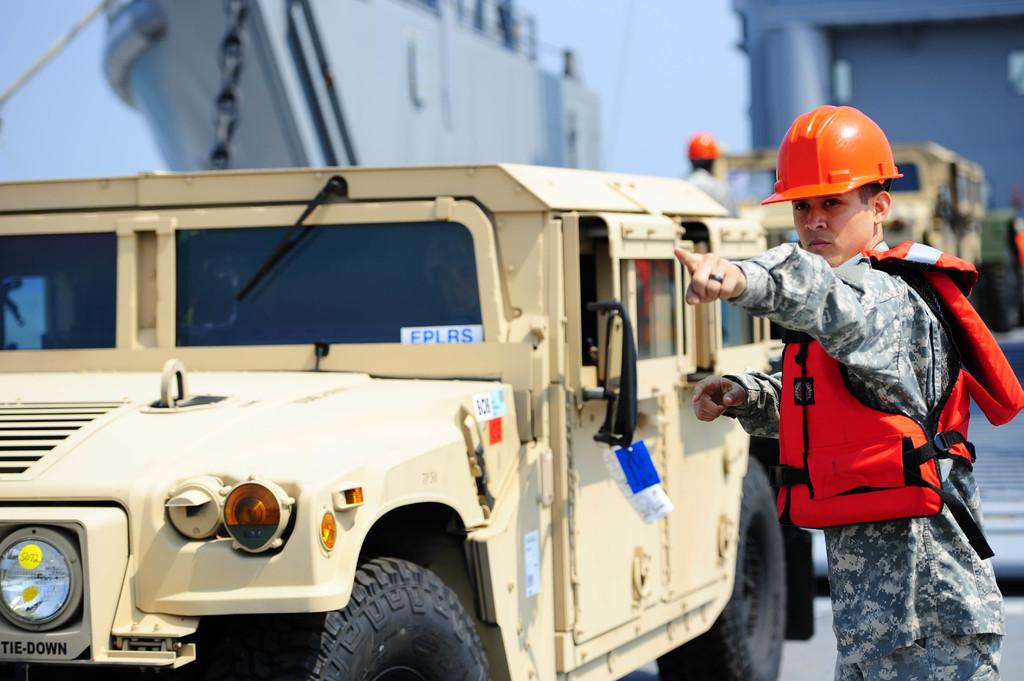How many cars are present in the image? There are two cars in the image. What else can be seen in the image besides the cars? There is a person standing in the image. What is the person wearing on their head? The person is wearing an orange color helmet. What type of clothing is the person wearing on their upper body? The person is wearing a jacket. What type of rod can be seen in the image? There is no rod present in the image. 